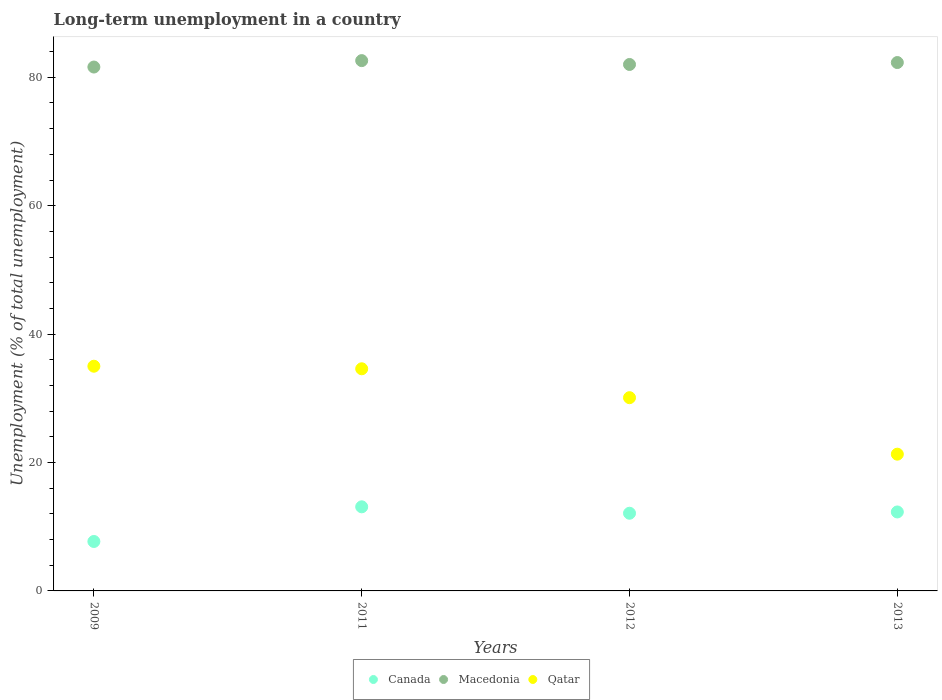Is the number of dotlines equal to the number of legend labels?
Your answer should be very brief. Yes. What is the percentage of long-term unemployed population in Macedonia in 2013?
Provide a short and direct response. 82.3. Across all years, what is the maximum percentage of long-term unemployed population in Canada?
Provide a succinct answer. 13.1. Across all years, what is the minimum percentage of long-term unemployed population in Canada?
Keep it short and to the point. 7.7. In which year was the percentage of long-term unemployed population in Qatar maximum?
Offer a very short reply. 2009. In which year was the percentage of long-term unemployed population in Macedonia minimum?
Your response must be concise. 2009. What is the total percentage of long-term unemployed population in Macedonia in the graph?
Your answer should be compact. 328.5. What is the difference between the percentage of long-term unemployed population in Macedonia in 2011 and that in 2013?
Provide a succinct answer. 0.3. What is the difference between the percentage of long-term unemployed population in Canada in 2011 and the percentage of long-term unemployed population in Qatar in 2009?
Your response must be concise. -21.9. What is the average percentage of long-term unemployed population in Macedonia per year?
Your answer should be very brief. 82.12. In the year 2011, what is the difference between the percentage of long-term unemployed population in Macedonia and percentage of long-term unemployed population in Canada?
Your answer should be very brief. 69.5. In how many years, is the percentage of long-term unemployed population in Canada greater than 72 %?
Make the answer very short. 0. What is the ratio of the percentage of long-term unemployed population in Qatar in 2012 to that in 2013?
Give a very brief answer. 1.41. Is the difference between the percentage of long-term unemployed population in Macedonia in 2012 and 2013 greater than the difference between the percentage of long-term unemployed population in Canada in 2012 and 2013?
Keep it short and to the point. No. What is the difference between the highest and the second highest percentage of long-term unemployed population in Canada?
Your answer should be compact. 0.8. In how many years, is the percentage of long-term unemployed population in Macedonia greater than the average percentage of long-term unemployed population in Macedonia taken over all years?
Offer a terse response. 2. Does the percentage of long-term unemployed population in Canada monotonically increase over the years?
Keep it short and to the point. No. How many dotlines are there?
Your response must be concise. 3. How many years are there in the graph?
Offer a very short reply. 4. How many legend labels are there?
Your response must be concise. 3. How are the legend labels stacked?
Provide a short and direct response. Horizontal. What is the title of the graph?
Your answer should be very brief. Long-term unemployment in a country. Does "Japan" appear as one of the legend labels in the graph?
Keep it short and to the point. No. What is the label or title of the X-axis?
Keep it short and to the point. Years. What is the label or title of the Y-axis?
Offer a terse response. Unemployment (% of total unemployment). What is the Unemployment (% of total unemployment) of Canada in 2009?
Your answer should be compact. 7.7. What is the Unemployment (% of total unemployment) in Macedonia in 2009?
Provide a succinct answer. 81.6. What is the Unemployment (% of total unemployment) of Canada in 2011?
Make the answer very short. 13.1. What is the Unemployment (% of total unemployment) of Macedonia in 2011?
Provide a short and direct response. 82.6. What is the Unemployment (% of total unemployment) of Qatar in 2011?
Give a very brief answer. 34.6. What is the Unemployment (% of total unemployment) in Canada in 2012?
Your answer should be compact. 12.1. What is the Unemployment (% of total unemployment) of Qatar in 2012?
Make the answer very short. 30.1. What is the Unemployment (% of total unemployment) in Canada in 2013?
Provide a short and direct response. 12.3. What is the Unemployment (% of total unemployment) of Macedonia in 2013?
Provide a succinct answer. 82.3. What is the Unemployment (% of total unemployment) of Qatar in 2013?
Give a very brief answer. 21.3. Across all years, what is the maximum Unemployment (% of total unemployment) of Canada?
Ensure brevity in your answer.  13.1. Across all years, what is the maximum Unemployment (% of total unemployment) of Macedonia?
Make the answer very short. 82.6. Across all years, what is the maximum Unemployment (% of total unemployment) of Qatar?
Offer a very short reply. 35. Across all years, what is the minimum Unemployment (% of total unemployment) in Canada?
Offer a very short reply. 7.7. Across all years, what is the minimum Unemployment (% of total unemployment) in Macedonia?
Ensure brevity in your answer.  81.6. Across all years, what is the minimum Unemployment (% of total unemployment) of Qatar?
Give a very brief answer. 21.3. What is the total Unemployment (% of total unemployment) in Canada in the graph?
Provide a succinct answer. 45.2. What is the total Unemployment (% of total unemployment) in Macedonia in the graph?
Give a very brief answer. 328.5. What is the total Unemployment (% of total unemployment) of Qatar in the graph?
Provide a succinct answer. 121. What is the difference between the Unemployment (% of total unemployment) in Canada in 2009 and that in 2011?
Ensure brevity in your answer.  -5.4. What is the difference between the Unemployment (% of total unemployment) of Macedonia in 2009 and that in 2011?
Ensure brevity in your answer.  -1. What is the difference between the Unemployment (% of total unemployment) in Canada in 2009 and that in 2012?
Give a very brief answer. -4.4. What is the difference between the Unemployment (% of total unemployment) in Macedonia in 2009 and that in 2012?
Offer a terse response. -0.4. What is the difference between the Unemployment (% of total unemployment) of Canada in 2009 and that in 2013?
Give a very brief answer. -4.6. What is the difference between the Unemployment (% of total unemployment) in Qatar in 2009 and that in 2013?
Make the answer very short. 13.7. What is the difference between the Unemployment (% of total unemployment) in Qatar in 2011 and that in 2012?
Provide a succinct answer. 4.5. What is the difference between the Unemployment (% of total unemployment) in Canada in 2011 and that in 2013?
Offer a very short reply. 0.8. What is the difference between the Unemployment (% of total unemployment) of Macedonia in 2011 and that in 2013?
Offer a very short reply. 0.3. What is the difference between the Unemployment (% of total unemployment) of Qatar in 2012 and that in 2013?
Your response must be concise. 8.8. What is the difference between the Unemployment (% of total unemployment) in Canada in 2009 and the Unemployment (% of total unemployment) in Macedonia in 2011?
Your answer should be very brief. -74.9. What is the difference between the Unemployment (% of total unemployment) in Canada in 2009 and the Unemployment (% of total unemployment) in Qatar in 2011?
Keep it short and to the point. -26.9. What is the difference between the Unemployment (% of total unemployment) in Macedonia in 2009 and the Unemployment (% of total unemployment) in Qatar in 2011?
Offer a very short reply. 47. What is the difference between the Unemployment (% of total unemployment) in Canada in 2009 and the Unemployment (% of total unemployment) in Macedonia in 2012?
Provide a short and direct response. -74.3. What is the difference between the Unemployment (% of total unemployment) of Canada in 2009 and the Unemployment (% of total unemployment) of Qatar in 2012?
Ensure brevity in your answer.  -22.4. What is the difference between the Unemployment (% of total unemployment) of Macedonia in 2009 and the Unemployment (% of total unemployment) of Qatar in 2012?
Your response must be concise. 51.5. What is the difference between the Unemployment (% of total unemployment) of Canada in 2009 and the Unemployment (% of total unemployment) of Macedonia in 2013?
Offer a terse response. -74.6. What is the difference between the Unemployment (% of total unemployment) of Canada in 2009 and the Unemployment (% of total unemployment) of Qatar in 2013?
Give a very brief answer. -13.6. What is the difference between the Unemployment (% of total unemployment) in Macedonia in 2009 and the Unemployment (% of total unemployment) in Qatar in 2013?
Offer a very short reply. 60.3. What is the difference between the Unemployment (% of total unemployment) in Canada in 2011 and the Unemployment (% of total unemployment) in Macedonia in 2012?
Your answer should be compact. -68.9. What is the difference between the Unemployment (% of total unemployment) of Canada in 2011 and the Unemployment (% of total unemployment) of Qatar in 2012?
Offer a very short reply. -17. What is the difference between the Unemployment (% of total unemployment) of Macedonia in 2011 and the Unemployment (% of total unemployment) of Qatar in 2012?
Your answer should be compact. 52.5. What is the difference between the Unemployment (% of total unemployment) in Canada in 2011 and the Unemployment (% of total unemployment) in Macedonia in 2013?
Provide a succinct answer. -69.2. What is the difference between the Unemployment (% of total unemployment) in Canada in 2011 and the Unemployment (% of total unemployment) in Qatar in 2013?
Give a very brief answer. -8.2. What is the difference between the Unemployment (% of total unemployment) of Macedonia in 2011 and the Unemployment (% of total unemployment) of Qatar in 2013?
Make the answer very short. 61.3. What is the difference between the Unemployment (% of total unemployment) in Canada in 2012 and the Unemployment (% of total unemployment) in Macedonia in 2013?
Your answer should be very brief. -70.2. What is the difference between the Unemployment (% of total unemployment) of Canada in 2012 and the Unemployment (% of total unemployment) of Qatar in 2013?
Offer a terse response. -9.2. What is the difference between the Unemployment (% of total unemployment) in Macedonia in 2012 and the Unemployment (% of total unemployment) in Qatar in 2013?
Keep it short and to the point. 60.7. What is the average Unemployment (% of total unemployment) in Macedonia per year?
Provide a short and direct response. 82.12. What is the average Unemployment (% of total unemployment) of Qatar per year?
Offer a terse response. 30.25. In the year 2009, what is the difference between the Unemployment (% of total unemployment) of Canada and Unemployment (% of total unemployment) of Macedonia?
Provide a short and direct response. -73.9. In the year 2009, what is the difference between the Unemployment (% of total unemployment) in Canada and Unemployment (% of total unemployment) in Qatar?
Your answer should be very brief. -27.3. In the year 2009, what is the difference between the Unemployment (% of total unemployment) of Macedonia and Unemployment (% of total unemployment) of Qatar?
Provide a short and direct response. 46.6. In the year 2011, what is the difference between the Unemployment (% of total unemployment) in Canada and Unemployment (% of total unemployment) in Macedonia?
Offer a terse response. -69.5. In the year 2011, what is the difference between the Unemployment (% of total unemployment) in Canada and Unemployment (% of total unemployment) in Qatar?
Provide a succinct answer. -21.5. In the year 2012, what is the difference between the Unemployment (% of total unemployment) in Canada and Unemployment (% of total unemployment) in Macedonia?
Provide a short and direct response. -69.9. In the year 2012, what is the difference between the Unemployment (% of total unemployment) of Canada and Unemployment (% of total unemployment) of Qatar?
Provide a succinct answer. -18. In the year 2012, what is the difference between the Unemployment (% of total unemployment) of Macedonia and Unemployment (% of total unemployment) of Qatar?
Your response must be concise. 51.9. In the year 2013, what is the difference between the Unemployment (% of total unemployment) in Canada and Unemployment (% of total unemployment) in Macedonia?
Offer a very short reply. -70. In the year 2013, what is the difference between the Unemployment (% of total unemployment) of Canada and Unemployment (% of total unemployment) of Qatar?
Ensure brevity in your answer.  -9. In the year 2013, what is the difference between the Unemployment (% of total unemployment) in Macedonia and Unemployment (% of total unemployment) in Qatar?
Provide a short and direct response. 61. What is the ratio of the Unemployment (% of total unemployment) in Canada in 2009 to that in 2011?
Your response must be concise. 0.59. What is the ratio of the Unemployment (% of total unemployment) in Macedonia in 2009 to that in 2011?
Your response must be concise. 0.99. What is the ratio of the Unemployment (% of total unemployment) of Qatar in 2009 to that in 2011?
Offer a terse response. 1.01. What is the ratio of the Unemployment (% of total unemployment) of Canada in 2009 to that in 2012?
Offer a very short reply. 0.64. What is the ratio of the Unemployment (% of total unemployment) in Macedonia in 2009 to that in 2012?
Your answer should be very brief. 1. What is the ratio of the Unemployment (% of total unemployment) in Qatar in 2009 to that in 2012?
Your answer should be very brief. 1.16. What is the ratio of the Unemployment (% of total unemployment) in Canada in 2009 to that in 2013?
Provide a succinct answer. 0.63. What is the ratio of the Unemployment (% of total unemployment) in Qatar in 2009 to that in 2013?
Provide a short and direct response. 1.64. What is the ratio of the Unemployment (% of total unemployment) of Canada in 2011 to that in 2012?
Your answer should be compact. 1.08. What is the ratio of the Unemployment (% of total unemployment) in Macedonia in 2011 to that in 2012?
Make the answer very short. 1.01. What is the ratio of the Unemployment (% of total unemployment) of Qatar in 2011 to that in 2012?
Ensure brevity in your answer.  1.15. What is the ratio of the Unemployment (% of total unemployment) in Canada in 2011 to that in 2013?
Your answer should be compact. 1.06. What is the ratio of the Unemployment (% of total unemployment) in Macedonia in 2011 to that in 2013?
Provide a short and direct response. 1. What is the ratio of the Unemployment (% of total unemployment) in Qatar in 2011 to that in 2013?
Keep it short and to the point. 1.62. What is the ratio of the Unemployment (% of total unemployment) in Canada in 2012 to that in 2013?
Your answer should be very brief. 0.98. What is the ratio of the Unemployment (% of total unemployment) in Qatar in 2012 to that in 2013?
Your answer should be very brief. 1.41. What is the difference between the highest and the second highest Unemployment (% of total unemployment) of Macedonia?
Offer a very short reply. 0.3. 